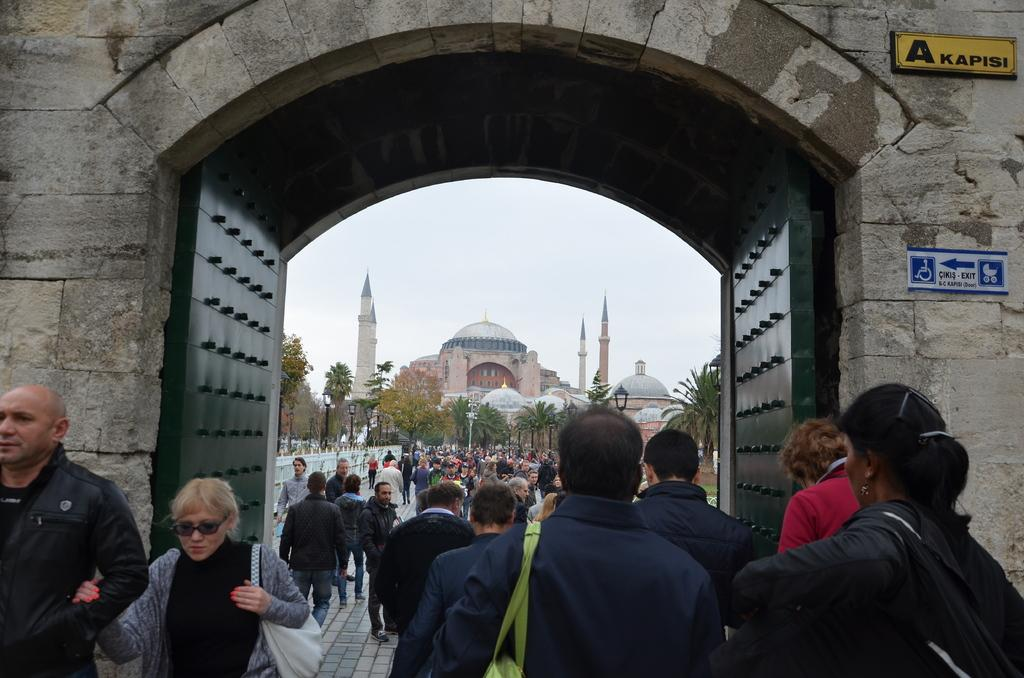How many people are in the group visible in the image? There is a group of people in the image, but the exact number cannot be determined from the provided facts. What can be seen in the background of the image? There are trees, poles, a building, and the sky visible in the background of the image. What architectural features are present in the image? There are gates and a wall present in the image. What is attached to the wall in the image? There are boards attached to the wall in the image. What condition are the friends' pull toys in the image? There is no mention of friends or pull toys in the image, so it is not possible to answer this question. 